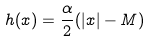Convert formula to latex. <formula><loc_0><loc_0><loc_500><loc_500>h ( x ) = \frac { \alpha } { 2 } ( | x | - M )</formula> 